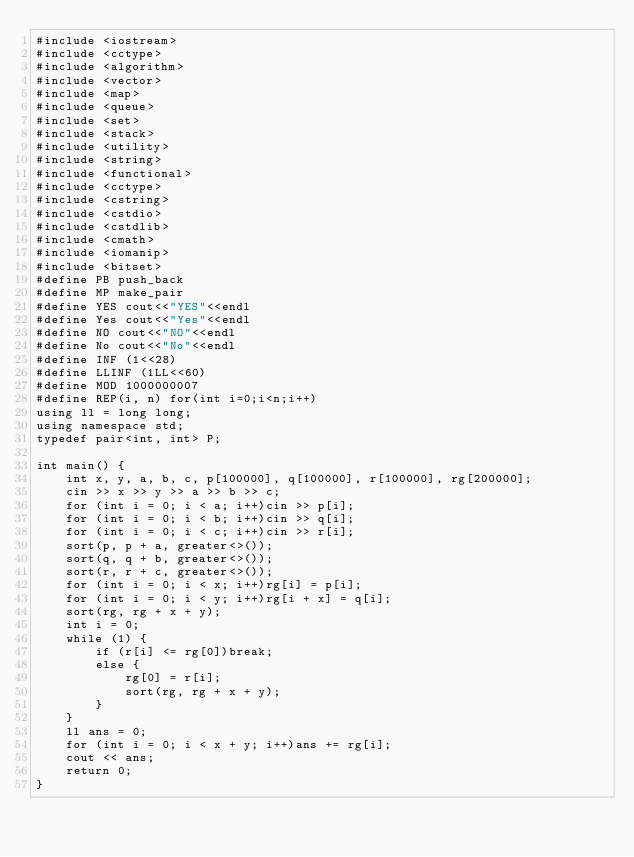<code> <loc_0><loc_0><loc_500><loc_500><_C++_>#include <iostream>
#include <cctype>
#include <algorithm>
#include <vector>
#include <map>
#include <queue>
#include <set>
#include <stack>
#include <utility>
#include <string>
#include <functional>
#include <cctype>
#include <cstring>
#include <cstdio>
#include <cstdlib>
#include <cmath>
#include <iomanip>
#include <bitset>
#define PB push_back
#define MP make_pair
#define YES cout<<"YES"<<endl
#define Yes cout<<"Yes"<<endl
#define NO cout<<"NO"<<endl
#define No cout<<"No"<<endl
#define INF (1<<28)
#define LLINF (1LL<<60)
#define MOD 1000000007
#define REP(i, n) for(int i=0;i<n;i++)
using ll = long long;
using namespace std;
typedef pair<int, int> P;

int main() {
    int x, y, a, b, c, p[100000], q[100000], r[100000], rg[200000];
    cin >> x >> y >> a >> b >> c;
    for (int i = 0; i < a; i++)cin >> p[i];
    for (int i = 0; i < b; i++)cin >> q[i];
    for (int i = 0; i < c; i++)cin >> r[i];
    sort(p, p + a, greater<>());
    sort(q, q + b, greater<>());
    sort(r, r + c, greater<>());
    for (int i = 0; i < x; i++)rg[i] = p[i];
    for (int i = 0; i < y; i++)rg[i + x] = q[i];
    sort(rg, rg + x + y);
    int i = 0;
    while (1) {
        if (r[i] <= rg[0])break;
        else {
            rg[0] = r[i];
            sort(rg, rg + x + y);
        }
    }
    ll ans = 0;
    for (int i = 0; i < x + y; i++)ans += rg[i];
    cout << ans;
    return 0;
}
</code> 